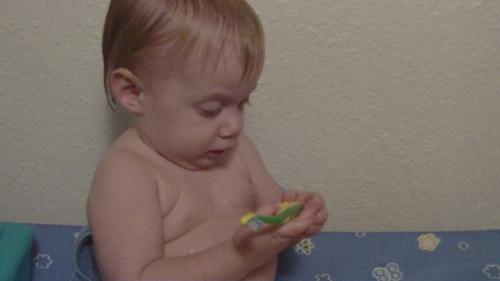What is the baby looking at?
Give a very brief answer. Toy. Is the baby scared or curious?
Answer briefly. Curious. What is the baby holding?
Write a very short answer. Toothbrush. What is being used to feed the baby?
Be succinct. Nothing. 